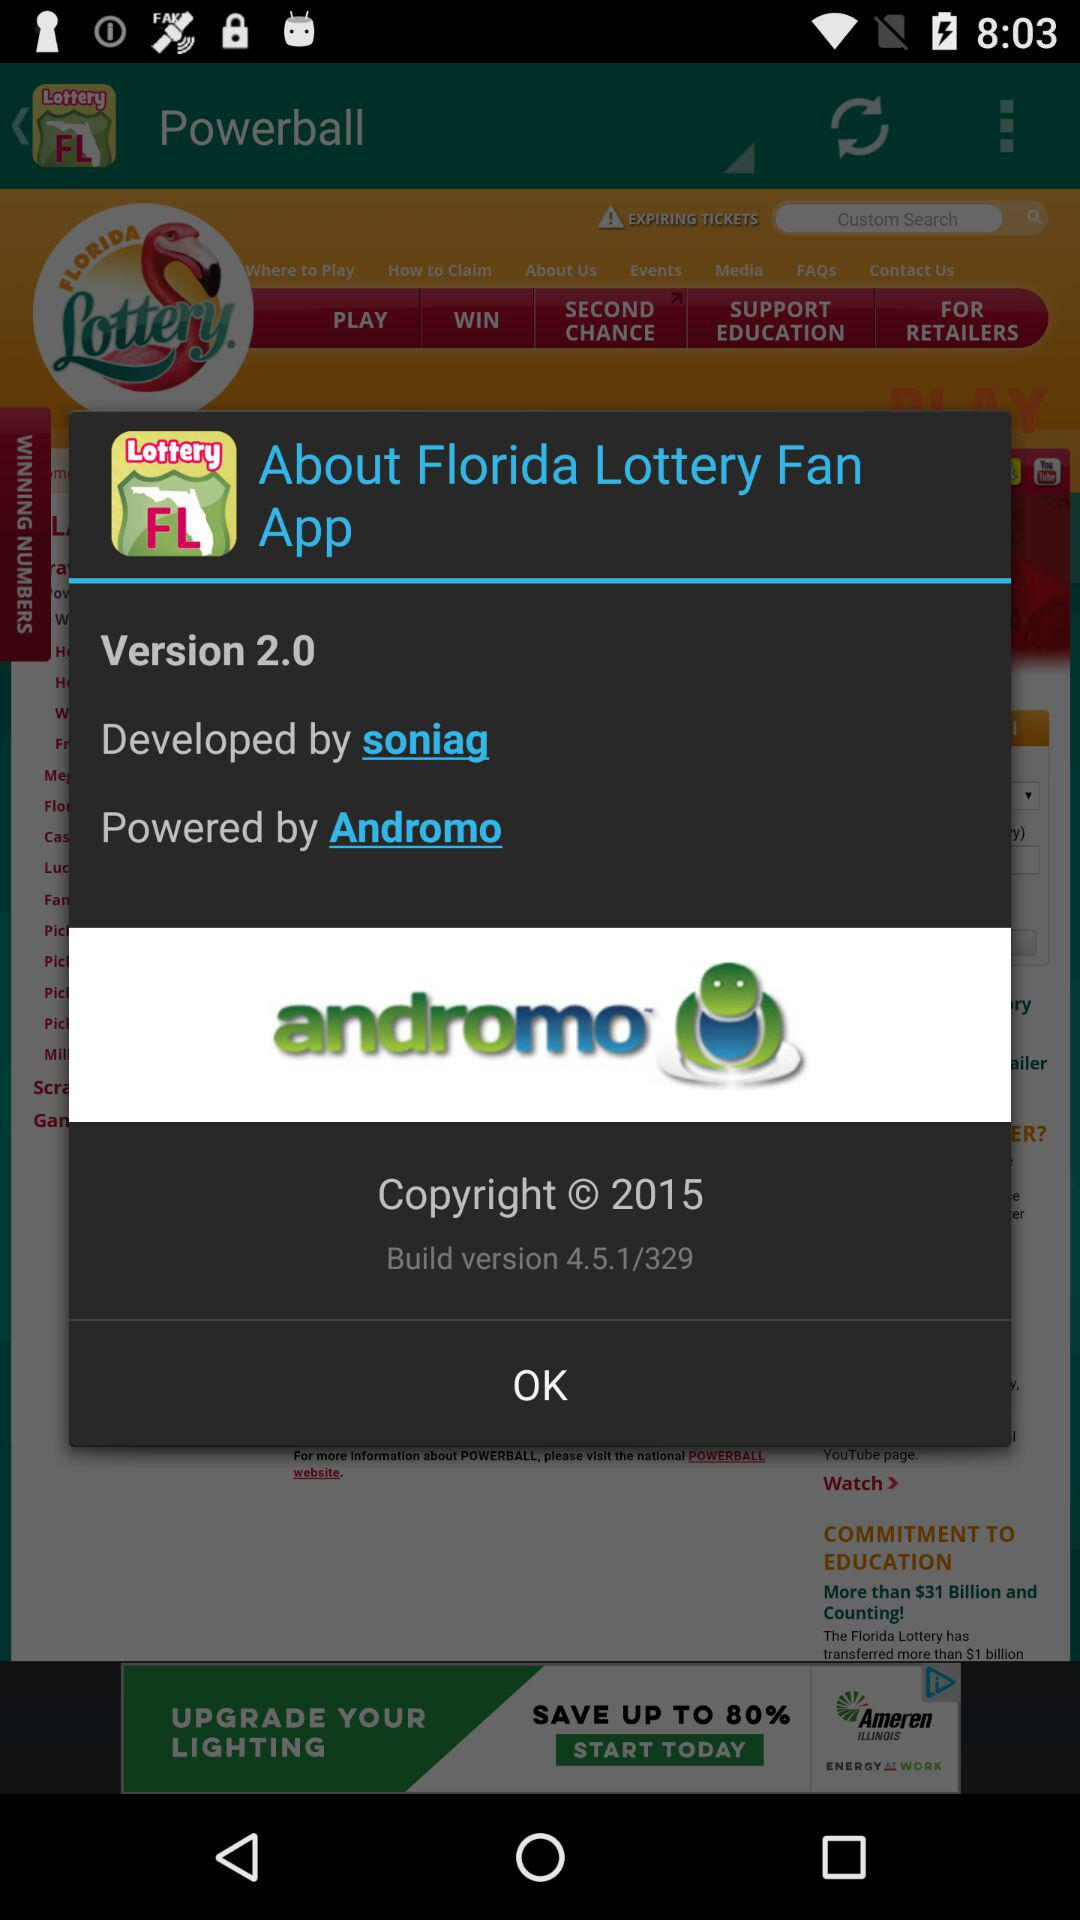What is the name of the application? The application name is "Florida Lottery Fan". 